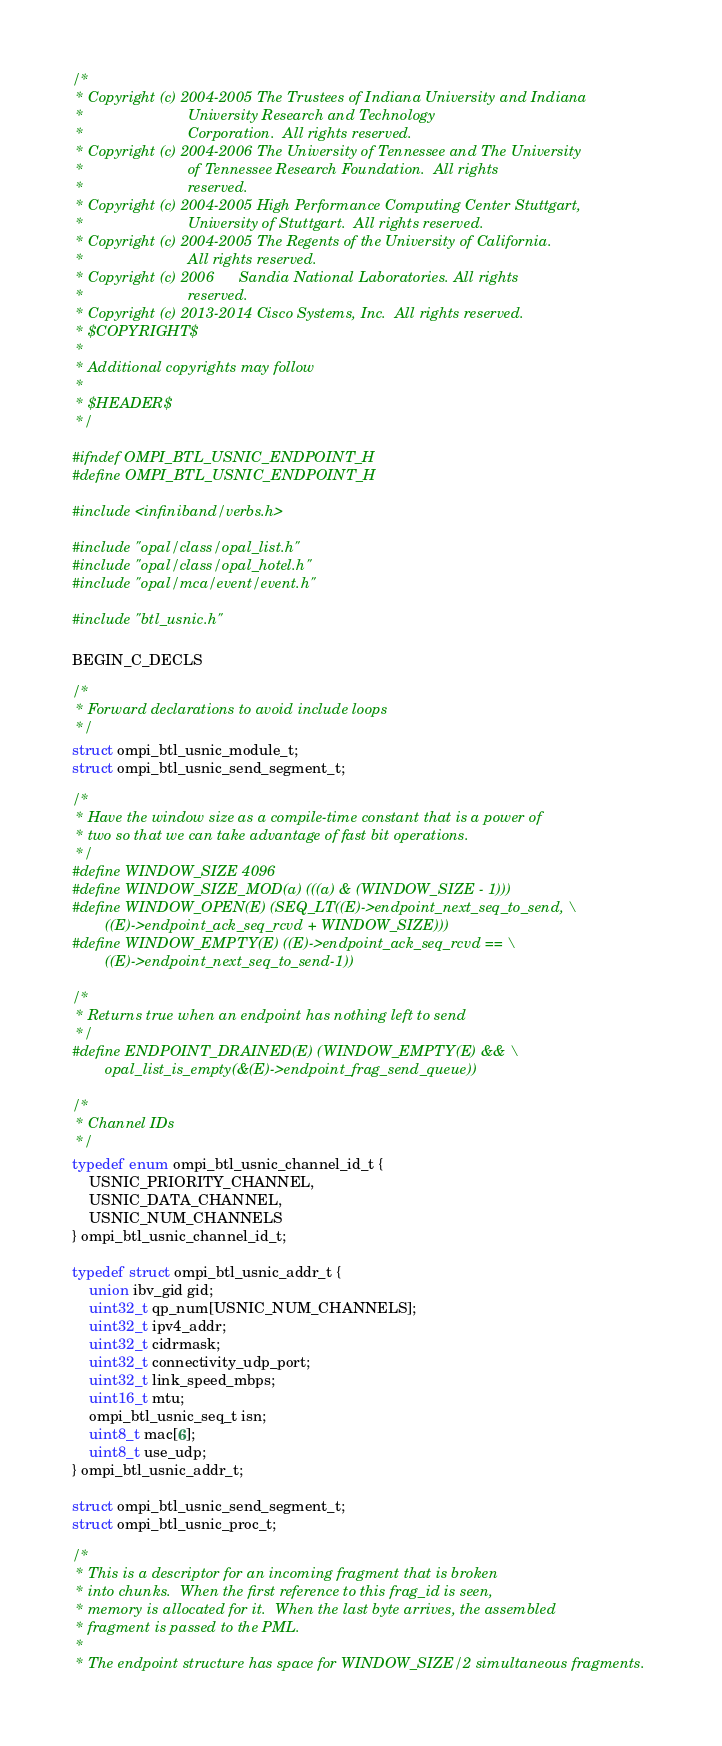<code> <loc_0><loc_0><loc_500><loc_500><_C_>/*
 * Copyright (c) 2004-2005 The Trustees of Indiana University and Indiana
 *                         University Research and Technology
 *                         Corporation.  All rights reserved.
 * Copyright (c) 2004-2006 The University of Tennessee and The University
 *                         of Tennessee Research Foundation.  All rights
 *                         reserved.
 * Copyright (c) 2004-2005 High Performance Computing Center Stuttgart,
 *                         University of Stuttgart.  All rights reserved.
 * Copyright (c) 2004-2005 The Regents of the University of California.
 *                         All rights reserved.
 * Copyright (c) 2006      Sandia National Laboratories. All rights
 *                         reserved.
 * Copyright (c) 2013-2014 Cisco Systems, Inc.  All rights reserved.
 * $COPYRIGHT$
 *
 * Additional copyrights may follow
 *
 * $HEADER$
 */

#ifndef OMPI_BTL_USNIC_ENDPOINT_H
#define OMPI_BTL_USNIC_ENDPOINT_H

#include <infiniband/verbs.h>

#include "opal/class/opal_list.h"
#include "opal/class/opal_hotel.h"
#include "opal/mca/event/event.h"

#include "btl_usnic.h"

BEGIN_C_DECLS

/*
 * Forward declarations to avoid include loops
 */
struct ompi_btl_usnic_module_t;
struct ompi_btl_usnic_send_segment_t;

/*
 * Have the window size as a compile-time constant that is a power of
 * two so that we can take advantage of fast bit operations.
 */
#define WINDOW_SIZE 4096
#define WINDOW_SIZE_MOD(a) (((a) & (WINDOW_SIZE - 1)))
#define WINDOW_OPEN(E) (SEQ_LT((E)->endpoint_next_seq_to_send, \
        ((E)->endpoint_ack_seq_rcvd + WINDOW_SIZE)))
#define WINDOW_EMPTY(E) ((E)->endpoint_ack_seq_rcvd == \
        ((E)->endpoint_next_seq_to_send-1))

/*
 * Returns true when an endpoint has nothing left to send
 */
#define ENDPOINT_DRAINED(E) (WINDOW_EMPTY(E) && \
        opal_list_is_empty(&(E)->endpoint_frag_send_queue))

/*
 * Channel IDs
 */
typedef enum ompi_btl_usnic_channel_id_t {
    USNIC_PRIORITY_CHANNEL,
    USNIC_DATA_CHANNEL,
    USNIC_NUM_CHANNELS
} ompi_btl_usnic_channel_id_t;

typedef struct ompi_btl_usnic_addr_t {
    union ibv_gid gid;
    uint32_t qp_num[USNIC_NUM_CHANNELS];
    uint32_t ipv4_addr;
    uint32_t cidrmask;
    uint32_t connectivity_udp_port;
    uint32_t link_speed_mbps;
    uint16_t mtu;
    ompi_btl_usnic_seq_t isn;
    uint8_t mac[6];
    uint8_t use_udp;
} ompi_btl_usnic_addr_t;

struct ompi_btl_usnic_send_segment_t;
struct ompi_btl_usnic_proc_t;

/*
 * This is a descriptor for an incoming fragment that is broken
 * into chunks.  When the first reference to this frag_id is seen,
 * memory is allocated for it.  When the last byte arrives, the assembled
 * fragment is passed to the PML.
 *
 * The endpoint structure has space for WINDOW_SIZE/2 simultaneous fragments.</code> 